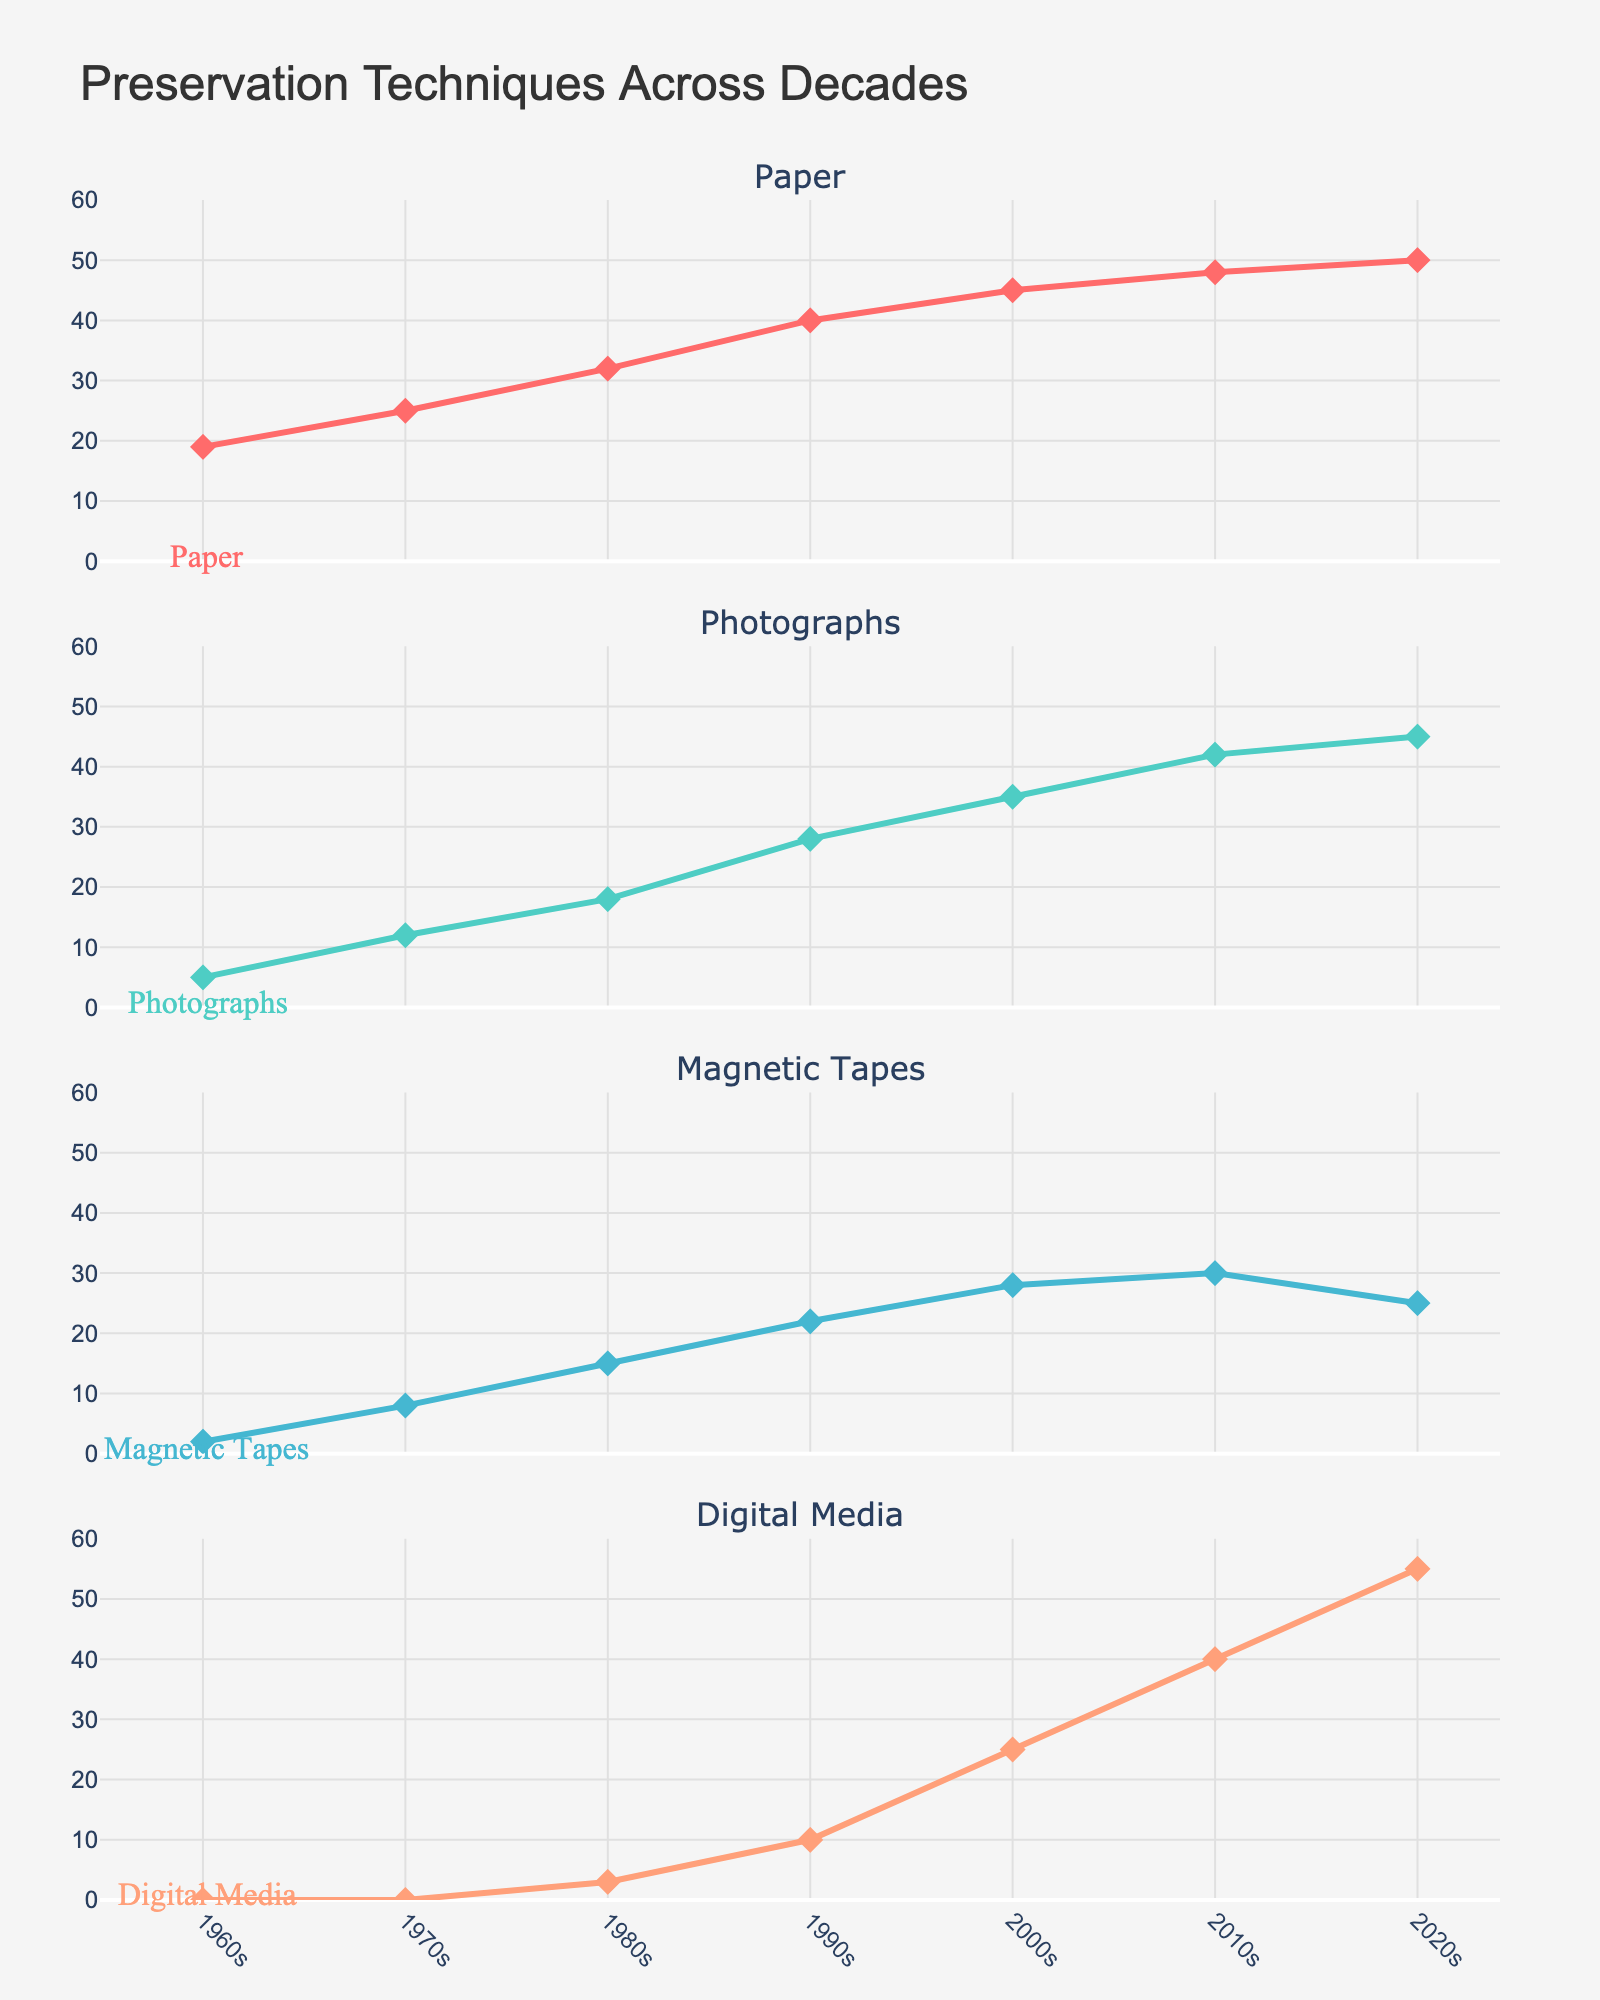What is the title of the figure? The title is written at the top of the subplot figure.
Answer: Preservation Techniques Across Decades Which decade shows the smallest value for Magnetic Tapes preservation techniques? By examining the subplot for Magnetic Tapes, the lowest value appears in the 1960s with a value of 2.
Answer: 1960s How many data points are shown for Photographs? Each subplot represents data points for every decade from the 1960s to the 2020s, totaling 7 data points.
Answer: 7 Which preservation technique shows a trend decreasing in value in the 2020s compared to the 2010s? By comparing the values from 2010s to 2020s across all subplots, it's clear that Magnetic Tapes reduction from 30 to 25 shows a decrease.
Answer: Magnetic Tapes What is the difference between the 2010s and 2020s values for Digital Media? Subtracting the 2010s value (40) from the 2020s value (55) for Digital Media yields a difference of 15.
Answer: 15 Which material experienced the largest increase in preservation techniques from the 1960s to the 2020s? Comparing the values for each material, Digital Media increased the most, from 0 in the 1960s to 55 in the 2020s.
Answer: Digital Media What's the color used to represent Photographs in the figure? The subplot title, annotations, and line color for Photographs consistently appear in a light greenish color.
Answer: Light green Calculate the average value of preservation techniques for Paper across all decades. Summing all the values for Paper (19+25+32+40+45+48+50) gives 259. Dividing by 7 decades gives an average of approximately 37.
Answer: 37 Which material surpasses 40 preservation techniques by 2000s the earliest? By examining each subplot, it is evident that Paper surpasses 40 techniques by the 2000s, while other materials do not reach 40 until later.
Answer: Paper Are there any decades where the values for all four materials either increase or stay constant, compared to the previous decade? Observing all the subplots together reveals that values increase or remain constant across all four materials from the 1960s to latter decades.
Answer: Yes 